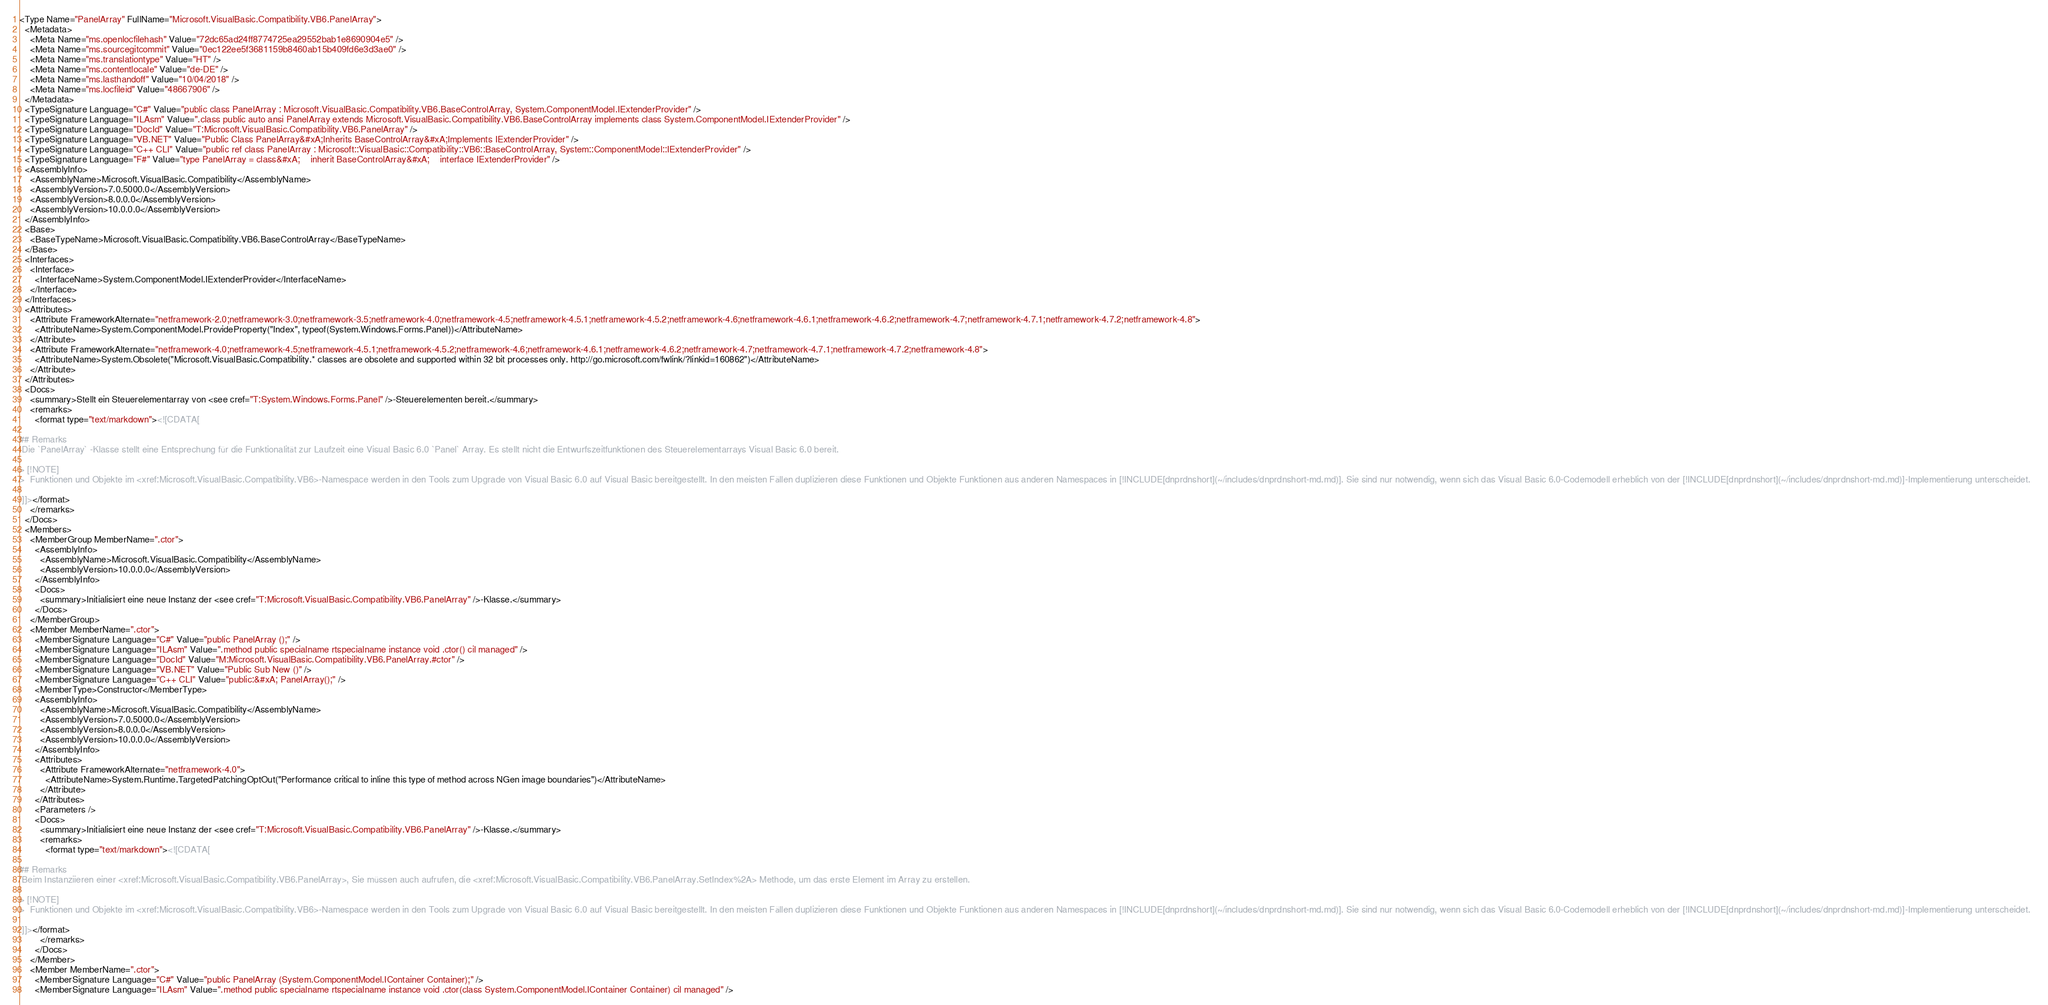<code> <loc_0><loc_0><loc_500><loc_500><_XML_><Type Name="PanelArray" FullName="Microsoft.VisualBasic.Compatibility.VB6.PanelArray">
  <Metadata>
    <Meta Name="ms.openlocfilehash" Value="72dc65ad24ff8774725ea29552bab1e8690904e5" />
    <Meta Name="ms.sourcegitcommit" Value="0ec122ee5f3681159b8460ab15b409fd6e3d3ae0" />
    <Meta Name="ms.translationtype" Value="HT" />
    <Meta Name="ms.contentlocale" Value="de-DE" />
    <Meta Name="ms.lasthandoff" Value="10/04/2018" />
    <Meta Name="ms.locfileid" Value="48667906" />
  </Metadata>
  <TypeSignature Language="C#" Value="public class PanelArray : Microsoft.VisualBasic.Compatibility.VB6.BaseControlArray, System.ComponentModel.IExtenderProvider" />
  <TypeSignature Language="ILAsm" Value=".class public auto ansi PanelArray extends Microsoft.VisualBasic.Compatibility.VB6.BaseControlArray implements class System.ComponentModel.IExtenderProvider" />
  <TypeSignature Language="DocId" Value="T:Microsoft.VisualBasic.Compatibility.VB6.PanelArray" />
  <TypeSignature Language="VB.NET" Value="Public Class PanelArray&#xA;Inherits BaseControlArray&#xA;Implements IExtenderProvider" />
  <TypeSignature Language="C++ CLI" Value="public ref class PanelArray : Microsoft::VisualBasic::Compatibility::VB6::BaseControlArray, System::ComponentModel::IExtenderProvider" />
  <TypeSignature Language="F#" Value="type PanelArray = class&#xA;    inherit BaseControlArray&#xA;    interface IExtenderProvider" />
  <AssemblyInfo>
    <AssemblyName>Microsoft.VisualBasic.Compatibility</AssemblyName>
    <AssemblyVersion>7.0.5000.0</AssemblyVersion>
    <AssemblyVersion>8.0.0.0</AssemblyVersion>
    <AssemblyVersion>10.0.0.0</AssemblyVersion>
  </AssemblyInfo>
  <Base>
    <BaseTypeName>Microsoft.VisualBasic.Compatibility.VB6.BaseControlArray</BaseTypeName>
  </Base>
  <Interfaces>
    <Interface>
      <InterfaceName>System.ComponentModel.IExtenderProvider</InterfaceName>
    </Interface>
  </Interfaces>
  <Attributes>
    <Attribute FrameworkAlternate="netframework-2.0;netframework-3.0;netframework-3.5;netframework-4.0;netframework-4.5;netframework-4.5.1;netframework-4.5.2;netframework-4.6;netframework-4.6.1;netframework-4.6.2;netframework-4.7;netframework-4.7.1;netframework-4.7.2;netframework-4.8">
      <AttributeName>System.ComponentModel.ProvideProperty("Index", typeof(System.Windows.Forms.Panel))</AttributeName>
    </Attribute>
    <Attribute FrameworkAlternate="netframework-4.0;netframework-4.5;netframework-4.5.1;netframework-4.5.2;netframework-4.6;netframework-4.6.1;netframework-4.6.2;netframework-4.7;netframework-4.7.1;netframework-4.7.2;netframework-4.8">
      <AttributeName>System.Obsolete("Microsoft.VisualBasic.Compatibility.* classes are obsolete and supported within 32 bit processes only. http://go.microsoft.com/fwlink/?linkid=160862")</AttributeName>
    </Attribute>
  </Attributes>
  <Docs>
    <summary>Stellt ein Steuerelementarray von <see cref="T:System.Windows.Forms.Panel" />-Steuerelementen bereit.</summary>
    <remarks>
      <format type="text/markdown"><![CDATA[  
  
## Remarks  
 Die `PanelArray` -Klasse stellt eine Entsprechung für die Funktionalität zur Laufzeit eine Visual Basic 6.0 `Panel` Array. Es stellt nicht die Entwurfszeitfunktionen des Steuerelementarrays Visual Basic 6.0 bereit.  
  
> [!NOTE]
>  Funktionen und Objekte im <xref:Microsoft.VisualBasic.Compatibility.VB6>-Namespace werden in den Tools zum Upgrade von Visual Basic 6.0 auf Visual Basic bereitgestellt. In den meisten Fällen duplizieren diese Funktionen und Objekte Funktionen aus anderen Namespaces in [!INCLUDE[dnprdnshort](~/includes/dnprdnshort-md.md)]. Sie sind nur notwendig, wenn sich das Visual Basic 6.0-Codemodell erheblich von der [!INCLUDE[dnprdnshort](~/includes/dnprdnshort-md.md)]-Implementierung unterscheidet.  
  
 ]]></format>
    </remarks>
  </Docs>
  <Members>
    <MemberGroup MemberName=".ctor">
      <AssemblyInfo>
        <AssemblyName>Microsoft.VisualBasic.Compatibility</AssemblyName>
        <AssemblyVersion>10.0.0.0</AssemblyVersion>
      </AssemblyInfo>
      <Docs>
        <summary>Initialisiert eine neue Instanz der <see cref="T:Microsoft.VisualBasic.Compatibility.VB6.PanelArray" />-Klasse.</summary>
      </Docs>
    </MemberGroup>
    <Member MemberName=".ctor">
      <MemberSignature Language="C#" Value="public PanelArray ();" />
      <MemberSignature Language="ILAsm" Value=".method public specialname rtspecialname instance void .ctor() cil managed" />
      <MemberSignature Language="DocId" Value="M:Microsoft.VisualBasic.Compatibility.VB6.PanelArray.#ctor" />
      <MemberSignature Language="VB.NET" Value="Public Sub New ()" />
      <MemberSignature Language="C++ CLI" Value="public:&#xA; PanelArray();" />
      <MemberType>Constructor</MemberType>
      <AssemblyInfo>
        <AssemblyName>Microsoft.VisualBasic.Compatibility</AssemblyName>
        <AssemblyVersion>7.0.5000.0</AssemblyVersion>
        <AssemblyVersion>8.0.0.0</AssemblyVersion>
        <AssemblyVersion>10.0.0.0</AssemblyVersion>
      </AssemblyInfo>
      <Attributes>
        <Attribute FrameworkAlternate="netframework-4.0">
          <AttributeName>System.Runtime.TargetedPatchingOptOut("Performance critical to inline this type of method across NGen image boundaries")</AttributeName>
        </Attribute>
      </Attributes>
      <Parameters />
      <Docs>
        <summary>Initialisiert eine neue Instanz der <see cref="T:Microsoft.VisualBasic.Compatibility.VB6.PanelArray" />-Klasse.</summary>
        <remarks>
          <format type="text/markdown"><![CDATA[  
  
## Remarks  
 Beim Instanziieren einer <xref:Microsoft.VisualBasic.Compatibility.VB6.PanelArray>, Sie müssen auch aufrufen, die <xref:Microsoft.VisualBasic.Compatibility.VB6.PanelArray.SetIndex%2A> Methode, um das erste Element im Array zu erstellen.  
  
> [!NOTE]
>  Funktionen und Objekte im <xref:Microsoft.VisualBasic.Compatibility.VB6>-Namespace werden in den Tools zum Upgrade von Visual Basic 6.0 auf Visual Basic bereitgestellt. In den meisten Fällen duplizieren diese Funktionen und Objekte Funktionen aus anderen Namespaces in [!INCLUDE[dnprdnshort](~/includes/dnprdnshort-md.md)]. Sie sind nur notwendig, wenn sich das Visual Basic 6.0-Codemodell erheblich von der [!INCLUDE[dnprdnshort](~/includes/dnprdnshort-md.md)]-Implementierung unterscheidet.  
  
 ]]></format>
        </remarks>
      </Docs>
    </Member>
    <Member MemberName=".ctor">
      <MemberSignature Language="C#" Value="public PanelArray (System.ComponentModel.IContainer Container);" />
      <MemberSignature Language="ILAsm" Value=".method public specialname rtspecialname instance void .ctor(class System.ComponentModel.IContainer Container) cil managed" /></code> 